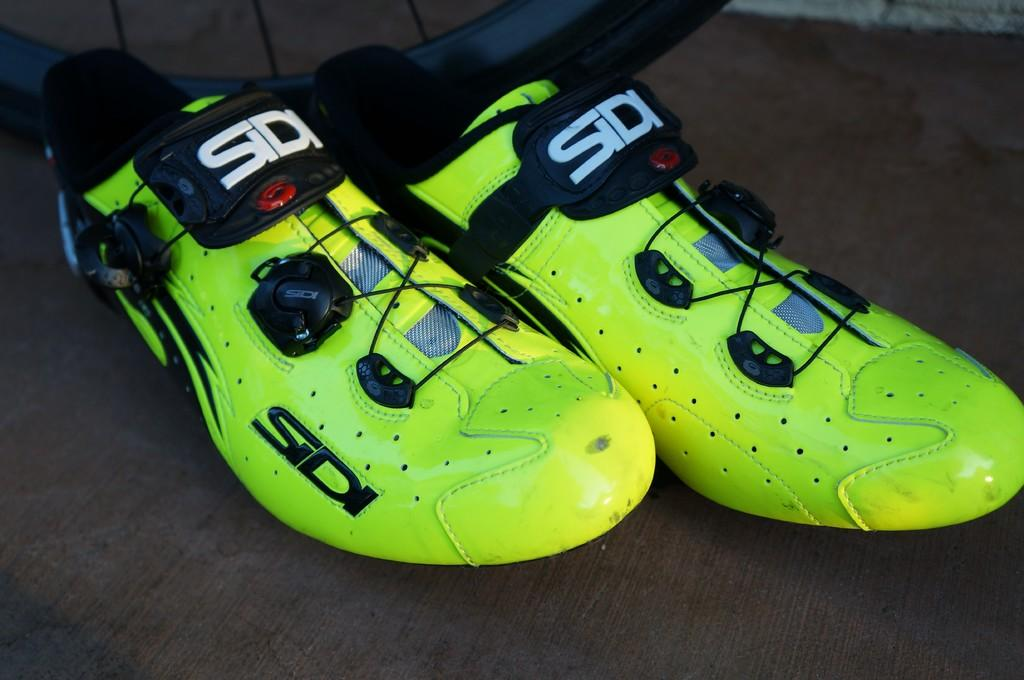What type of shoes are visible in the image? There are neon colored shoes in the image. Where are the shoes located? The shoes are on the floor. What other object can be seen in the image? There is a wheel of a bicycle in the image. How is the bicycle wheel positioned in relation to the shoes? The wheel is beside the shoes. What color is the boy's neck in the image? There is no boy present in the image, so we cannot determine the color of his neck. 